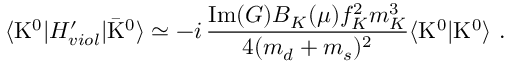Convert formula to latex. <formula><loc_0><loc_0><loc_500><loc_500>\langle K ^ { 0 } | H _ { v i o l } ^ { \prime } | \bar { K } ^ { 0 } \rangle \simeq - i \, \frac { I m ( G ) B _ { K } ( \mu ) f _ { K } ^ { 2 } m _ { K } ^ { 3 } } { 4 ( m _ { d } + m _ { s } ) ^ { 2 } } \langle K ^ { 0 } | { K } ^ { 0 } \rangle \ .</formula> 